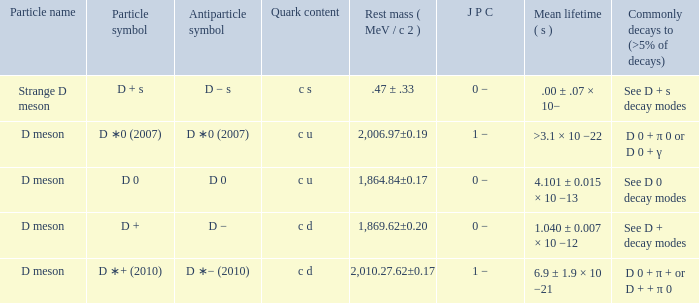What is the antiparticle symbol with a rest mess (mev/c2) of .47 ± .33? D − s. 